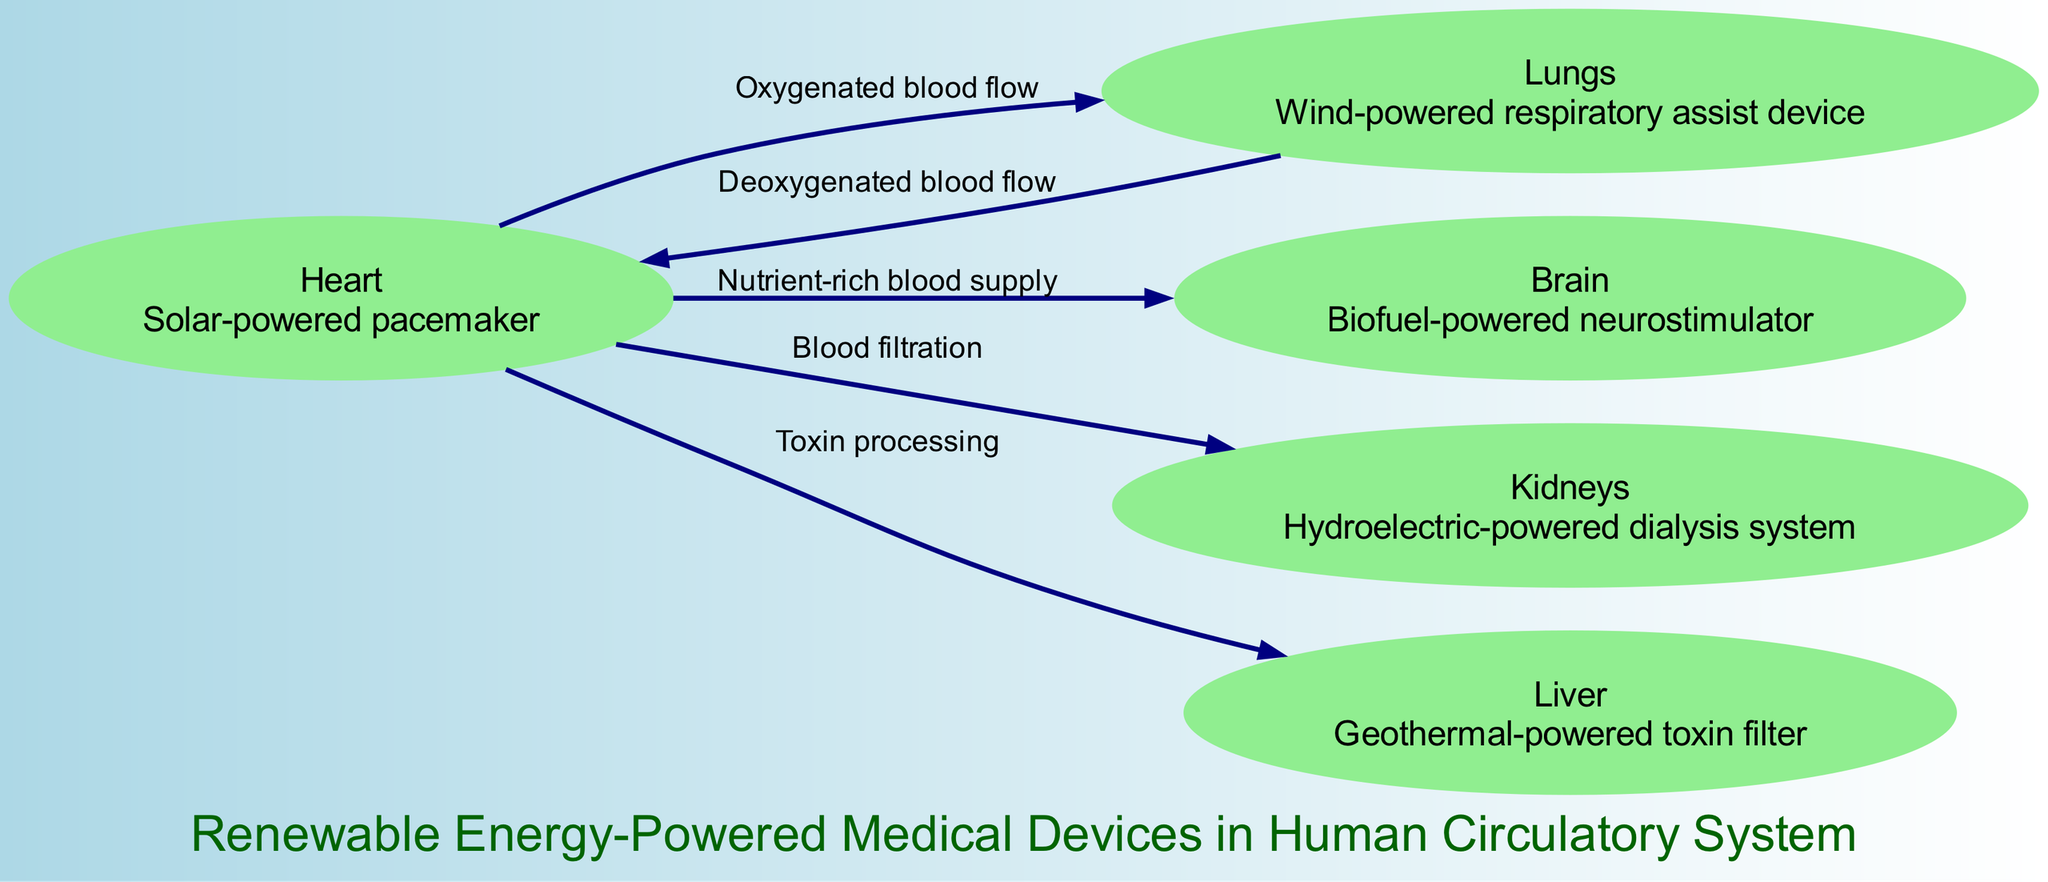What are the renewable energy sources integrated with the medical devices? The diagram shows five medical devices powered by renewable energy: a solar-powered pacemaker for the heart, a wind-powered respiratory assist device for the lungs, a biofuel-powered neurostimulator for the brain, a hydroelectric-powered dialysis system for the kidneys, and a geothermal-powered toxin filter for the liver.
Answer: Solar, wind, biofuel, hydroelectric, geothermal How many nodes are in the diagram? The nodes represent specific organs and their corresponding renewable energy-powered devices. There are a total of five nodes: heart, lungs, brain, kidneys, and liver. Therefore, the number of nodes is 5.
Answer: 5 What is the function of the device connected to the heart? The device associated with the heart is a solar-powered pacemaker, which regulates heart rhythms by providing electrical stimulation. According to the diagram, the heart's function is enhanced by this renewable energy device.
Answer: Solar-powered pacemaker Which organ receives nutrient-rich blood supply? The diagram connects the heart to the brain, indicating that the brain receives nutrient-rich blood supply from the heart, enhancing its functionality with proper nutrients.
Answer: Brain What type of energy powers the device for the kidneys? The kidneys are linked to a hydroelectric-powered dialysis system, which suggests that water-driven energy is utilized to filter blood, aiding patients with kidney function.
Answer: Hydroelectric How does deoxygenated blood flow back to the heart? The diagram depicts the flow from the lungs to the heart labeled as deoxygenated blood flow. This represents the pathway through which blood lacking oxygen returns to the heart after it has been oxygenated in the lungs.
Answer: Lungs to heart What process does the liver perform according to the diagram? The liver is shown processing toxins with a geothermal-powered toxin filter, indicating its role in detoxifying harmful substances from the blood, showcasing its vital function in the circulatory system.
Answer: Toxin processing What connects the heart and the kidneys in the diagram? The edge between the heart and kidneys is labeled "Blood filtration," signifying that the heart pumps blood to the kidneys after nutrient distribution. This highlights the kidneys' essential function in filtering the blood.
Answer: Blood filtration How many edges are depicted in the diagram? The connections or edges between the nodes represent various blood flow processes in the circulatory system. The diagram shows four edges: heart to lungs, lungs to heart, heart to brain, and heart to kidneys, indicating four distinct blood flow functions.
Answer: 4 What renewable energy source is associated with the lungs? The lungs have a wind-powered respiratory assist device connected to them, indicating that wind energy is used to support respiratory functions, enhancing the efficiency of breathing processes in patients.
Answer: Wind-powered respiratory assist device 